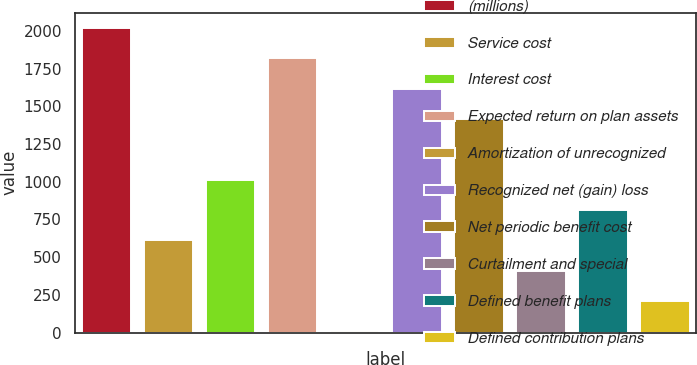<chart> <loc_0><loc_0><loc_500><loc_500><bar_chart><fcel>(millions)<fcel>Service cost<fcel>Interest cost<fcel>Expected return on plan assets<fcel>Amortization of unrecognized<fcel>Recognized net (gain) loss<fcel>Net periodic benefit cost<fcel>Curtailment and special<fcel>Defined benefit plans<fcel>Defined contribution plans<nl><fcel>2018<fcel>611<fcel>1013<fcel>1817<fcel>8<fcel>1616<fcel>1415<fcel>410<fcel>812<fcel>209<nl></chart> 